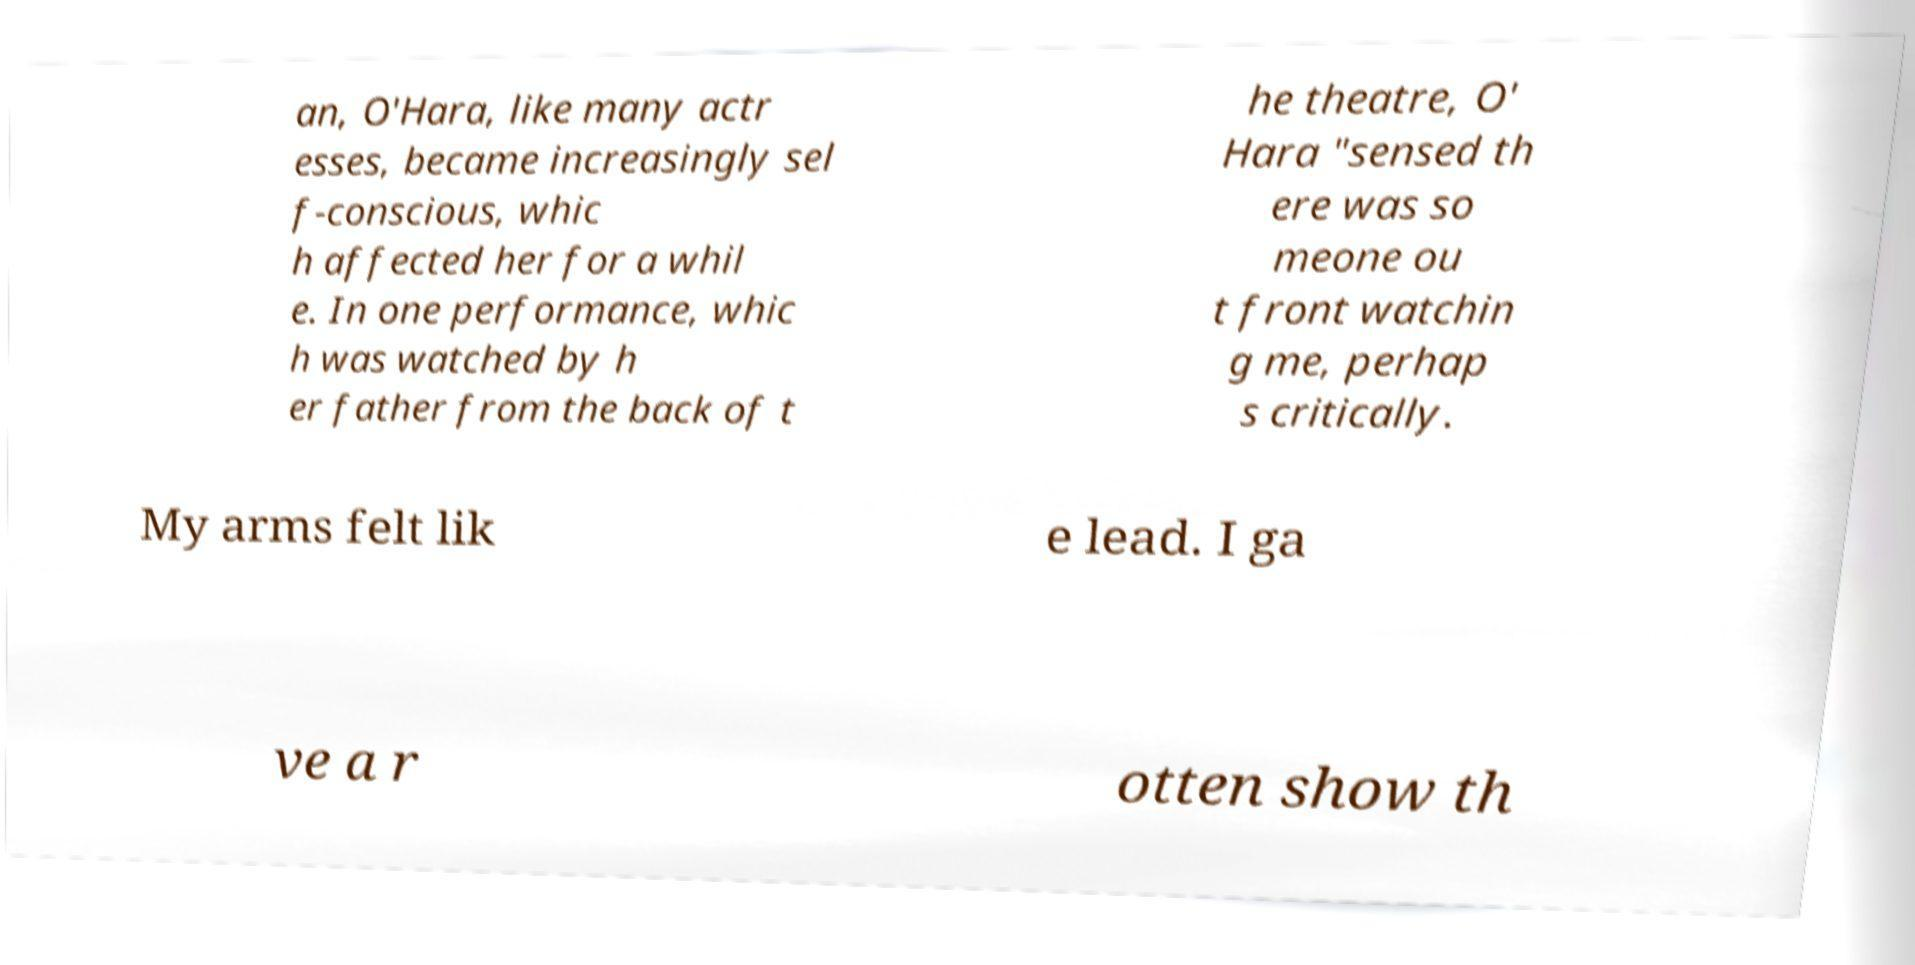Could you assist in decoding the text presented in this image and type it out clearly? an, O'Hara, like many actr esses, became increasingly sel f-conscious, whic h affected her for a whil e. In one performance, whic h was watched by h er father from the back of t he theatre, O' Hara "sensed th ere was so meone ou t front watchin g me, perhap s critically. My arms felt lik e lead. I ga ve a r otten show th 